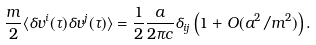<formula> <loc_0><loc_0><loc_500><loc_500>\frac { m } { 2 } \langle \delta v ^ { i } ( \tau ) \delta v ^ { j } ( \tau ) \rangle = \frac { 1 } { 2 } \frac { a } { 2 \pi c } \delta _ { i j } \left ( 1 + O ( a ^ { 2 } / m ^ { 2 } ) \right ) .</formula> 